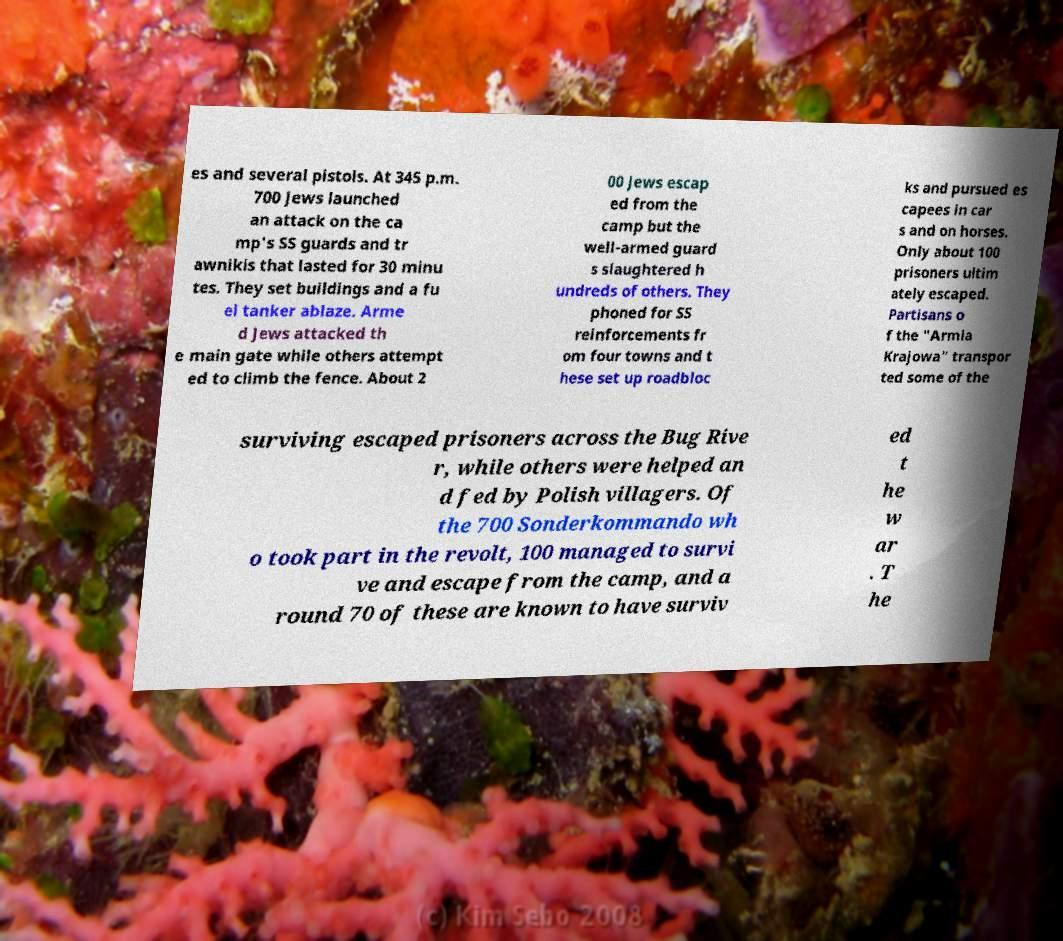Please read and relay the text visible in this image. What does it say? es and several pistols. At 345 p.m. 700 Jews launched an attack on the ca mp's SS guards and tr awnikis that lasted for 30 minu tes. They set buildings and a fu el tanker ablaze. Arme d Jews attacked th e main gate while others attempt ed to climb the fence. About 2 00 Jews escap ed from the camp but the well-armed guard s slaughtered h undreds of others. They phoned for SS reinforcements fr om four towns and t hese set up roadbloc ks and pursued es capees in car s and on horses. Only about 100 prisoners ultim ately escaped. Partisans o f the "Armia Krajowa" transpor ted some of the surviving escaped prisoners across the Bug Rive r, while others were helped an d fed by Polish villagers. Of the 700 Sonderkommando wh o took part in the revolt, 100 managed to survi ve and escape from the camp, and a round 70 of these are known to have surviv ed t he w ar . T he 